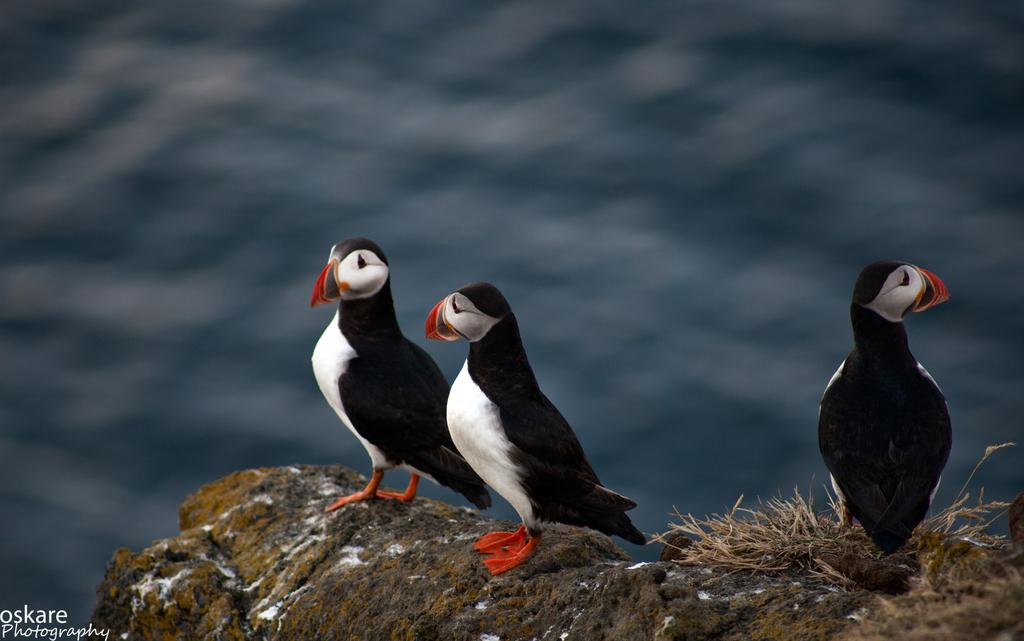What type of animals can be seen in the image? There are birds in the image. What colors can be observed on the birds? The birds have various colors, including black, white, orange, and red. What surface are the birds standing on? The birds are standing on a rock. What type of vegetation is visible in the image? There is grass visible in the image. What can be seen in the background of the image? There is water in the background of the image. What type of treatment is the bird receiving for its injured wing in the image? There is no indication in the image that any bird has an injured wing, nor is there any treatment being administered. 